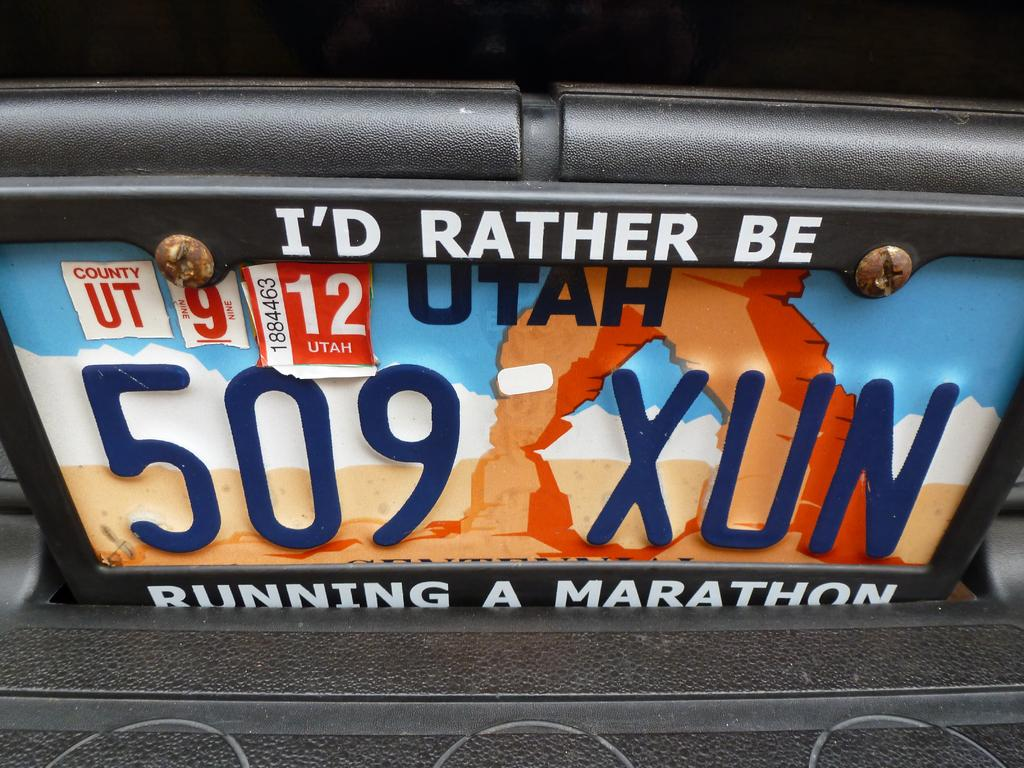Provide a one-sentence caption for the provided image. A license plate with a vanity holder displaying the words "I'd rather be running a marathon.". 